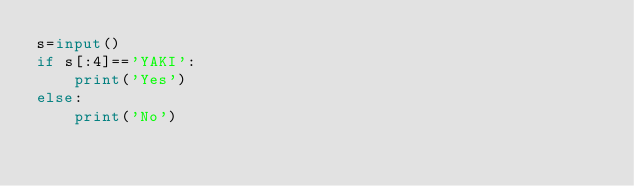Convert code to text. <code><loc_0><loc_0><loc_500><loc_500><_Python_>s=input()
if s[:4]=='YAKI':
    print('Yes')
else:
    print('No')
</code> 